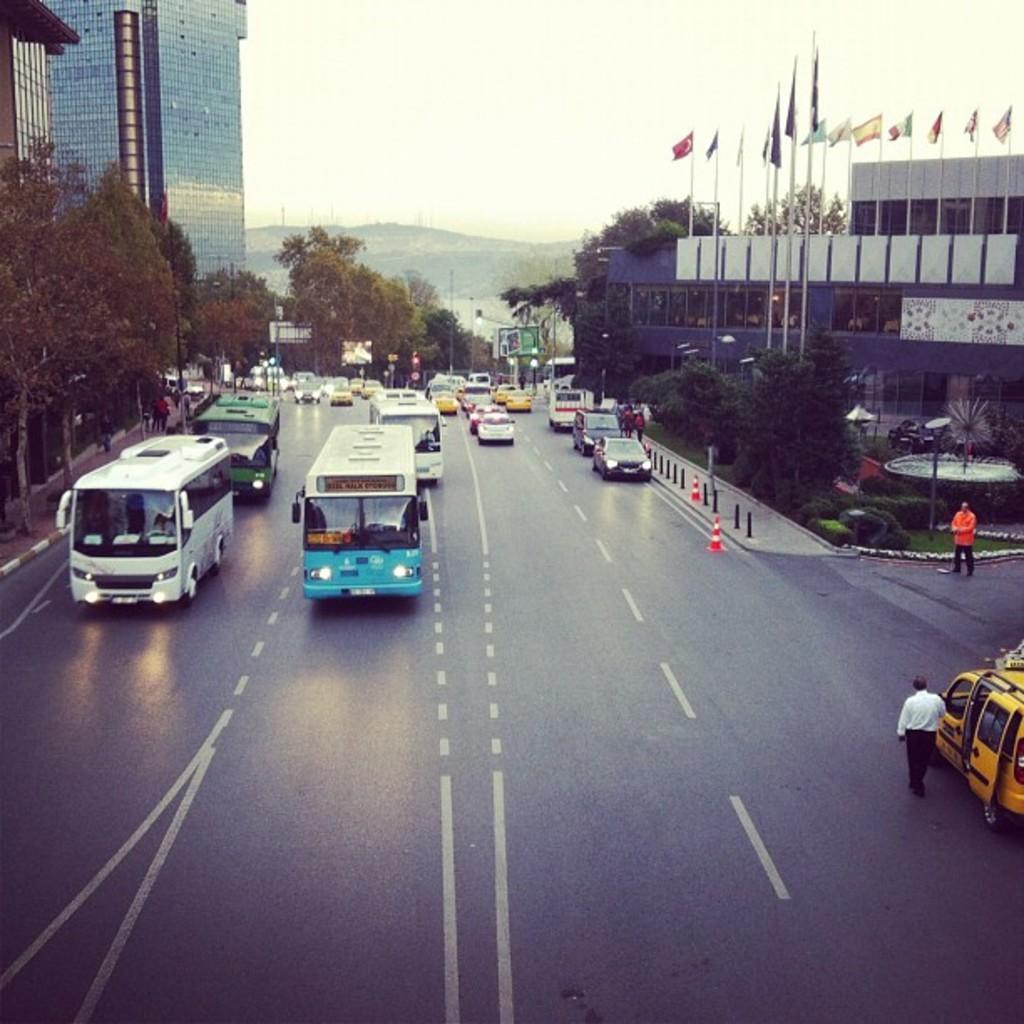In one or two sentences, can you explain what this image depicts? In this image, we can see some trees and buildings. There are vehicles on the road. There are two persons on the right side of the image wearing clothes. There are flags in the top right of the image. There is a sky at the top of the image. 